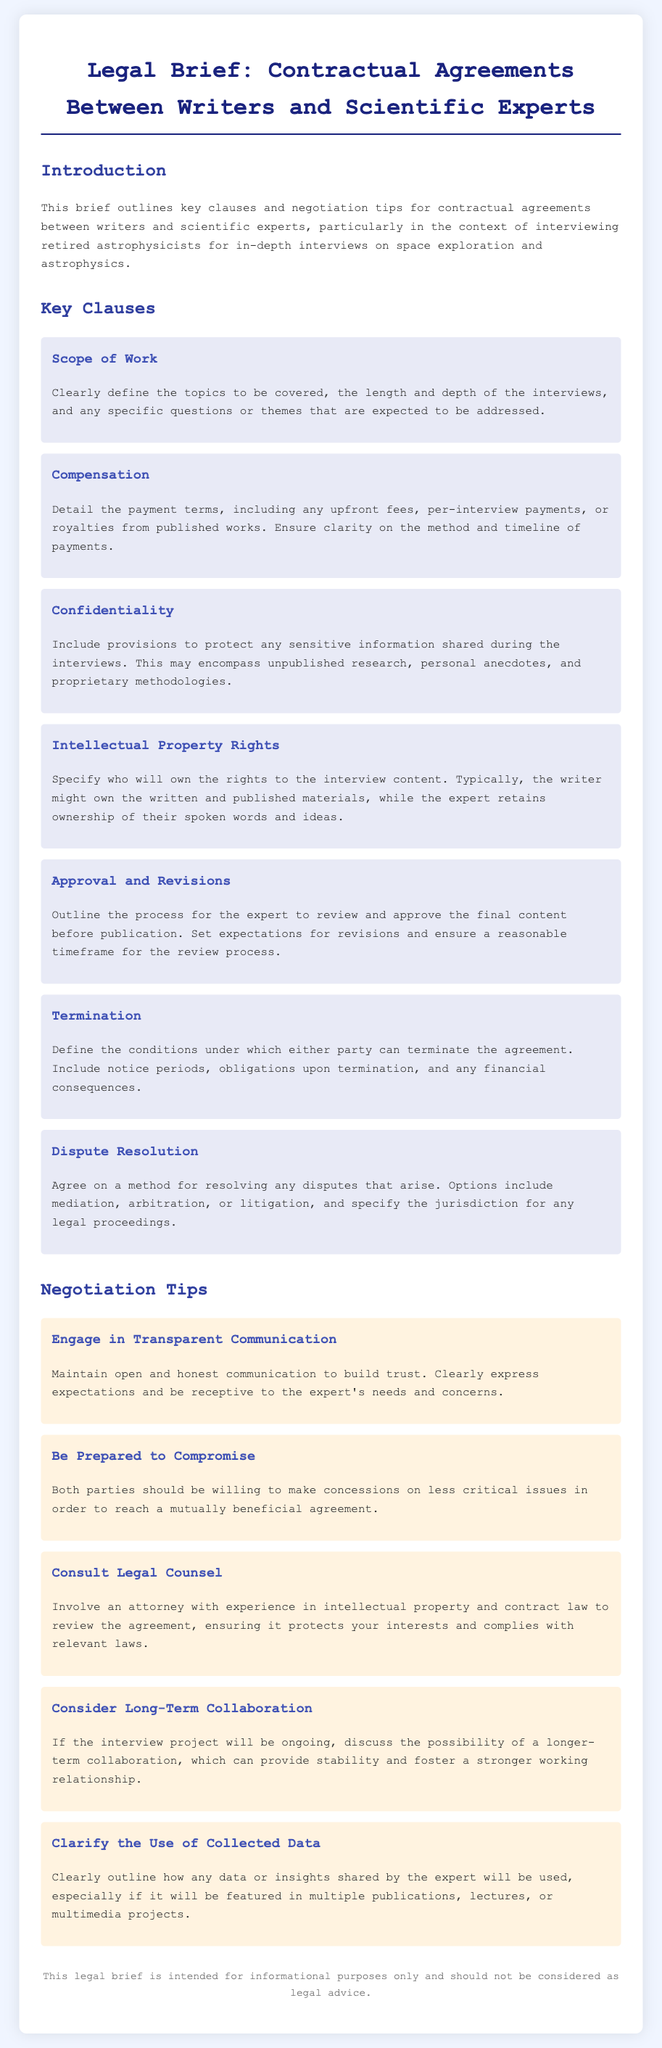What is the title of the document? The title of the document is indicated at the top and specifies the subject of the legal brief.
Answer: Legal Brief: Contractual Agreements Between Writers and Scientific Experts What is the first key clause listed? The first key clause is mentioned in a section specifically outlining critical aspects of agreements, detailing its subtitle.
Answer: Scope of Work How many negotiation tips are provided? The document counts the items listed in the Negotiation Tips section.
Answer: Five What is one type of dispute resolution mentioned? The type of resolution is noted in the context of handling disagreements as per the key clauses.
Answer: Mediation What is the primary purpose of this legal brief? The purpose is stated clearly in the introduction, focusing on the relationship between writers and scientific experts.
Answer: Informational purposes only What must be included in the compensation clause? The compensation clause outlines payment terms, which are crucial for understanding the financial agreements.
Answer: Payment terms What does the confidentiality clause protect? The types of information it aims to protect are explicitly mentioned under the confidentiality section of the legal brief.
Answer: Sensitive information Who should be involved in reviewing the agreement? The document specifies the type of professional consultation recommended for reviewing the contract to ensure legality and protection.
Answer: An attorney What is one of the negotiation tips provided? The tips are summarized elements intended to help in discussions between writers and experts, showing broad strategies.
Answer: Engage in Transparent Communication 